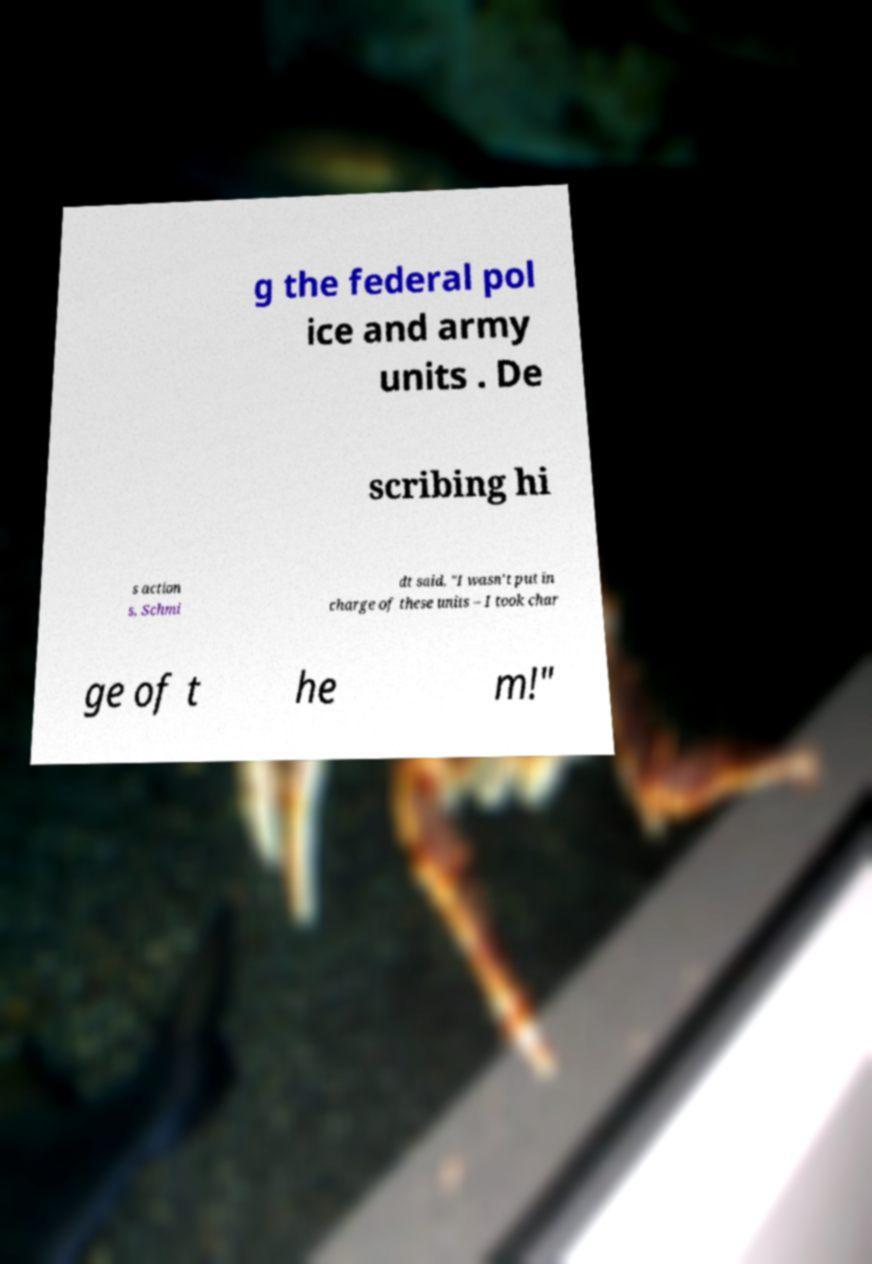What messages or text are displayed in this image? I need them in a readable, typed format. g the federal pol ice and army units . De scribing hi s action s, Schmi dt said, "I wasn't put in charge of these units – I took char ge of t he m!" 